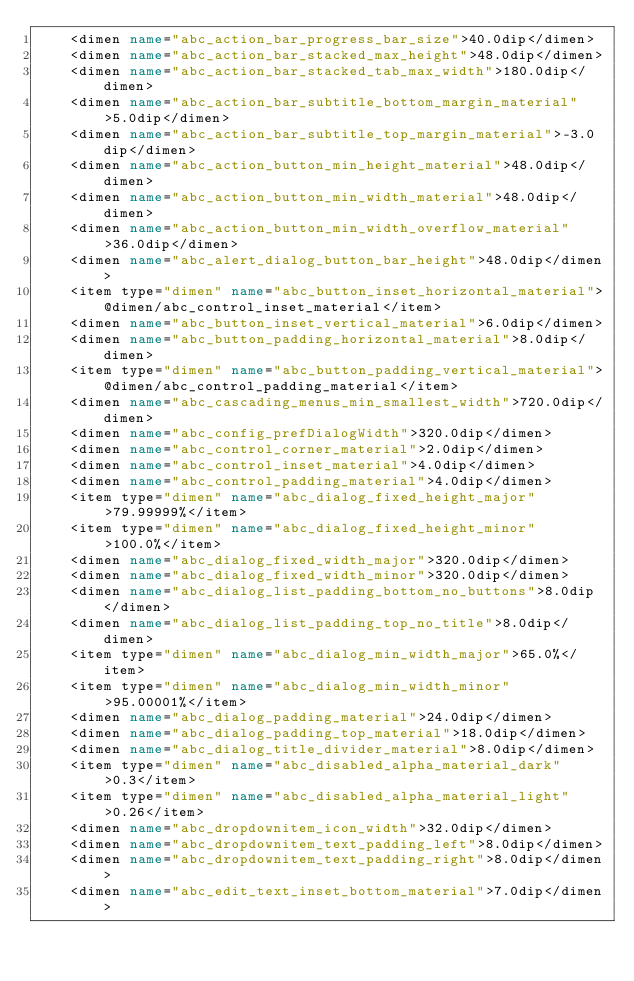Convert code to text. <code><loc_0><loc_0><loc_500><loc_500><_XML_>    <dimen name="abc_action_bar_progress_bar_size">40.0dip</dimen>
    <dimen name="abc_action_bar_stacked_max_height">48.0dip</dimen>
    <dimen name="abc_action_bar_stacked_tab_max_width">180.0dip</dimen>
    <dimen name="abc_action_bar_subtitle_bottom_margin_material">5.0dip</dimen>
    <dimen name="abc_action_bar_subtitle_top_margin_material">-3.0dip</dimen>
    <dimen name="abc_action_button_min_height_material">48.0dip</dimen>
    <dimen name="abc_action_button_min_width_material">48.0dip</dimen>
    <dimen name="abc_action_button_min_width_overflow_material">36.0dip</dimen>
    <dimen name="abc_alert_dialog_button_bar_height">48.0dip</dimen>
    <item type="dimen" name="abc_button_inset_horizontal_material">@dimen/abc_control_inset_material</item>
    <dimen name="abc_button_inset_vertical_material">6.0dip</dimen>
    <dimen name="abc_button_padding_horizontal_material">8.0dip</dimen>
    <item type="dimen" name="abc_button_padding_vertical_material">@dimen/abc_control_padding_material</item>
    <dimen name="abc_cascading_menus_min_smallest_width">720.0dip</dimen>
    <dimen name="abc_config_prefDialogWidth">320.0dip</dimen>
    <dimen name="abc_control_corner_material">2.0dip</dimen>
    <dimen name="abc_control_inset_material">4.0dip</dimen>
    <dimen name="abc_control_padding_material">4.0dip</dimen>
    <item type="dimen" name="abc_dialog_fixed_height_major">79.99999%</item>
    <item type="dimen" name="abc_dialog_fixed_height_minor">100.0%</item>
    <dimen name="abc_dialog_fixed_width_major">320.0dip</dimen>
    <dimen name="abc_dialog_fixed_width_minor">320.0dip</dimen>
    <dimen name="abc_dialog_list_padding_bottom_no_buttons">8.0dip</dimen>
    <dimen name="abc_dialog_list_padding_top_no_title">8.0dip</dimen>
    <item type="dimen" name="abc_dialog_min_width_major">65.0%</item>
    <item type="dimen" name="abc_dialog_min_width_minor">95.00001%</item>
    <dimen name="abc_dialog_padding_material">24.0dip</dimen>
    <dimen name="abc_dialog_padding_top_material">18.0dip</dimen>
    <dimen name="abc_dialog_title_divider_material">8.0dip</dimen>
    <item type="dimen" name="abc_disabled_alpha_material_dark">0.3</item>
    <item type="dimen" name="abc_disabled_alpha_material_light">0.26</item>
    <dimen name="abc_dropdownitem_icon_width">32.0dip</dimen>
    <dimen name="abc_dropdownitem_text_padding_left">8.0dip</dimen>
    <dimen name="abc_dropdownitem_text_padding_right">8.0dip</dimen>
    <dimen name="abc_edit_text_inset_bottom_material">7.0dip</dimen></code> 